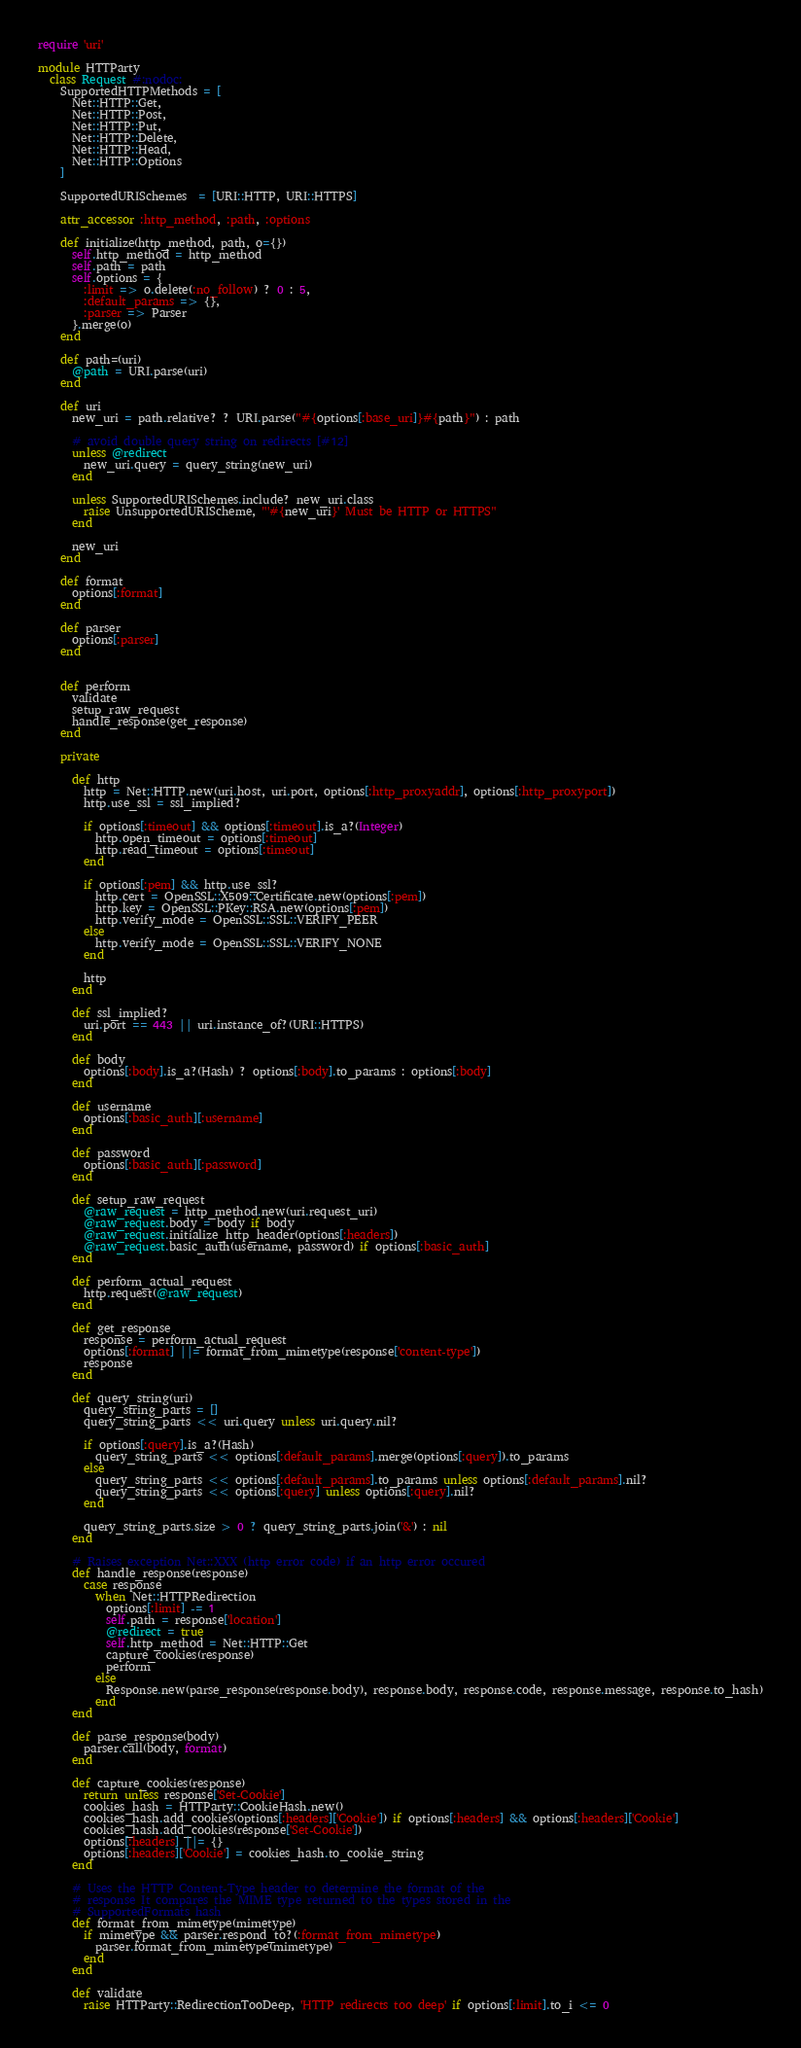<code> <loc_0><loc_0><loc_500><loc_500><_Ruby_>require 'uri'

module HTTParty
  class Request #:nodoc:
    SupportedHTTPMethods = [
      Net::HTTP::Get,
      Net::HTTP::Post,
      Net::HTTP::Put,
      Net::HTTP::Delete,
      Net::HTTP::Head,
      Net::HTTP::Options
    ]

    SupportedURISchemes  = [URI::HTTP, URI::HTTPS]

    attr_accessor :http_method, :path, :options

    def initialize(http_method, path, o={})
      self.http_method = http_method
      self.path = path
      self.options = {
        :limit => o.delete(:no_follow) ? 0 : 5,
        :default_params => {},
        :parser => Parser
      }.merge(o)
    end

    def path=(uri)
      @path = URI.parse(uri)
    end

    def uri
      new_uri = path.relative? ? URI.parse("#{options[:base_uri]}#{path}") : path

      # avoid double query string on redirects [#12]
      unless @redirect
        new_uri.query = query_string(new_uri)
      end

      unless SupportedURISchemes.include? new_uri.class
        raise UnsupportedURIScheme, "'#{new_uri}' Must be HTTP or HTTPS"
      end

      new_uri
    end

    def format
      options[:format]
    end

    def parser
      options[:parser]
    end


    def perform
      validate
      setup_raw_request
      handle_response(get_response)
    end

    private

      def http
        http = Net::HTTP.new(uri.host, uri.port, options[:http_proxyaddr], options[:http_proxyport])
        http.use_ssl = ssl_implied?

        if options[:timeout] && options[:timeout].is_a?(Integer)
          http.open_timeout = options[:timeout]
          http.read_timeout = options[:timeout]
        end

        if options[:pem] && http.use_ssl?
          http.cert = OpenSSL::X509::Certificate.new(options[:pem])
          http.key = OpenSSL::PKey::RSA.new(options[:pem])
          http.verify_mode = OpenSSL::SSL::VERIFY_PEER
        else
          http.verify_mode = OpenSSL::SSL::VERIFY_NONE
        end

        http
      end

      def ssl_implied?
        uri.port == 443 || uri.instance_of?(URI::HTTPS)
      end

      def body
        options[:body].is_a?(Hash) ? options[:body].to_params : options[:body]
      end

      def username
        options[:basic_auth][:username]
      end

      def password
        options[:basic_auth][:password]
      end

      def setup_raw_request
        @raw_request = http_method.new(uri.request_uri)
        @raw_request.body = body if body
        @raw_request.initialize_http_header(options[:headers])
        @raw_request.basic_auth(username, password) if options[:basic_auth]
      end

      def perform_actual_request
        http.request(@raw_request)
      end

      def get_response
        response = perform_actual_request
        options[:format] ||= format_from_mimetype(response['content-type'])
        response
      end

      def query_string(uri)
        query_string_parts = []
        query_string_parts << uri.query unless uri.query.nil?

        if options[:query].is_a?(Hash)
          query_string_parts << options[:default_params].merge(options[:query]).to_params
        else
          query_string_parts << options[:default_params].to_params unless options[:default_params].nil?
          query_string_parts << options[:query] unless options[:query].nil?
        end

        query_string_parts.size > 0 ? query_string_parts.join('&') : nil
      end

      # Raises exception Net::XXX (http error code) if an http error occured
      def handle_response(response)
        case response
          when Net::HTTPRedirection
            options[:limit] -= 1
            self.path = response['location']
            @redirect = true
            self.http_method = Net::HTTP::Get
            capture_cookies(response)
            perform
          else
            Response.new(parse_response(response.body), response.body, response.code, response.message, response.to_hash)
          end
      end

      def parse_response(body)
        parser.call(body, format)
      end

      def capture_cookies(response)
        return unless response['Set-Cookie']
        cookies_hash = HTTParty::CookieHash.new()
        cookies_hash.add_cookies(options[:headers]['Cookie']) if options[:headers] && options[:headers]['Cookie']
        cookies_hash.add_cookies(response['Set-Cookie'])
        options[:headers] ||= {}
        options[:headers]['Cookie'] = cookies_hash.to_cookie_string
      end

      # Uses the HTTP Content-Type header to determine the format of the
      # response It compares the MIME type returned to the types stored in the
      # SupportedFormats hash
      def format_from_mimetype(mimetype)
        if mimetype && parser.respond_to?(:format_from_mimetype)
          parser.format_from_mimetype(mimetype)
        end
      end

      def validate
        raise HTTParty::RedirectionTooDeep, 'HTTP redirects too deep' if options[:limit].to_i <= 0</code> 